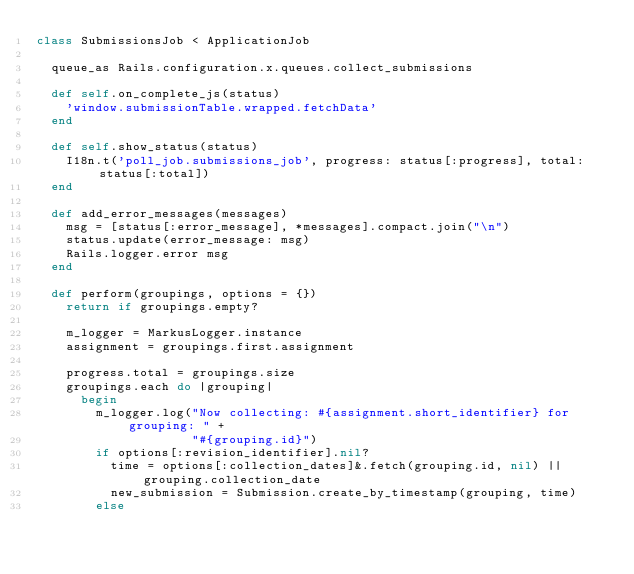Convert code to text. <code><loc_0><loc_0><loc_500><loc_500><_Ruby_>class SubmissionsJob < ApplicationJob

  queue_as Rails.configuration.x.queues.collect_submissions

  def self.on_complete_js(status)
    'window.submissionTable.wrapped.fetchData'
  end

  def self.show_status(status)
    I18n.t('poll_job.submissions_job', progress: status[:progress], total: status[:total])
  end

  def add_error_messages(messages)
    msg = [status[:error_message], *messages].compact.join("\n")
    status.update(error_message: msg)
    Rails.logger.error msg
  end

  def perform(groupings, options = {})
    return if groupings.empty?

    m_logger = MarkusLogger.instance
    assignment = groupings.first.assignment

    progress.total = groupings.size
    groupings.each do |grouping|
      begin
        m_logger.log("Now collecting: #{assignment.short_identifier} for grouping: " +
                     "#{grouping.id}")
        if options[:revision_identifier].nil?
          time = options[:collection_dates]&.fetch(grouping.id, nil) || grouping.collection_date
          new_submission = Submission.create_by_timestamp(grouping, time)
        else</code> 